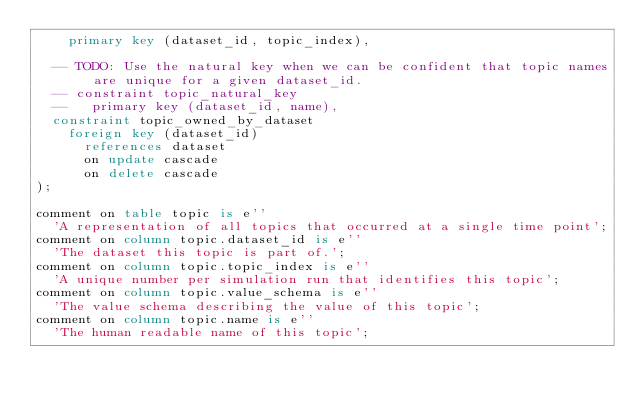<code> <loc_0><loc_0><loc_500><loc_500><_SQL_>    primary key (dataset_id, topic_index),

  -- TODO: Use the natural key when we can be confident that topic names are unique for a given dataset_id.
  -- constraint topic_natural_key
  --   primary key (dataset_id, name),
  constraint topic_owned_by_dataset
    foreign key (dataset_id)
      references dataset
      on update cascade
      on delete cascade
);

comment on table topic is e''
  'A representation of all topics that occurred at a single time point';
comment on column topic.dataset_id is e''
  'The dataset this topic is part of.';
comment on column topic.topic_index is e''
  'A unique number per simulation run that identifies this topic';
comment on column topic.value_schema is e''
  'The value schema describing the value of this topic';
comment on column topic.name is e''
  'The human readable name of this topic';
</code> 